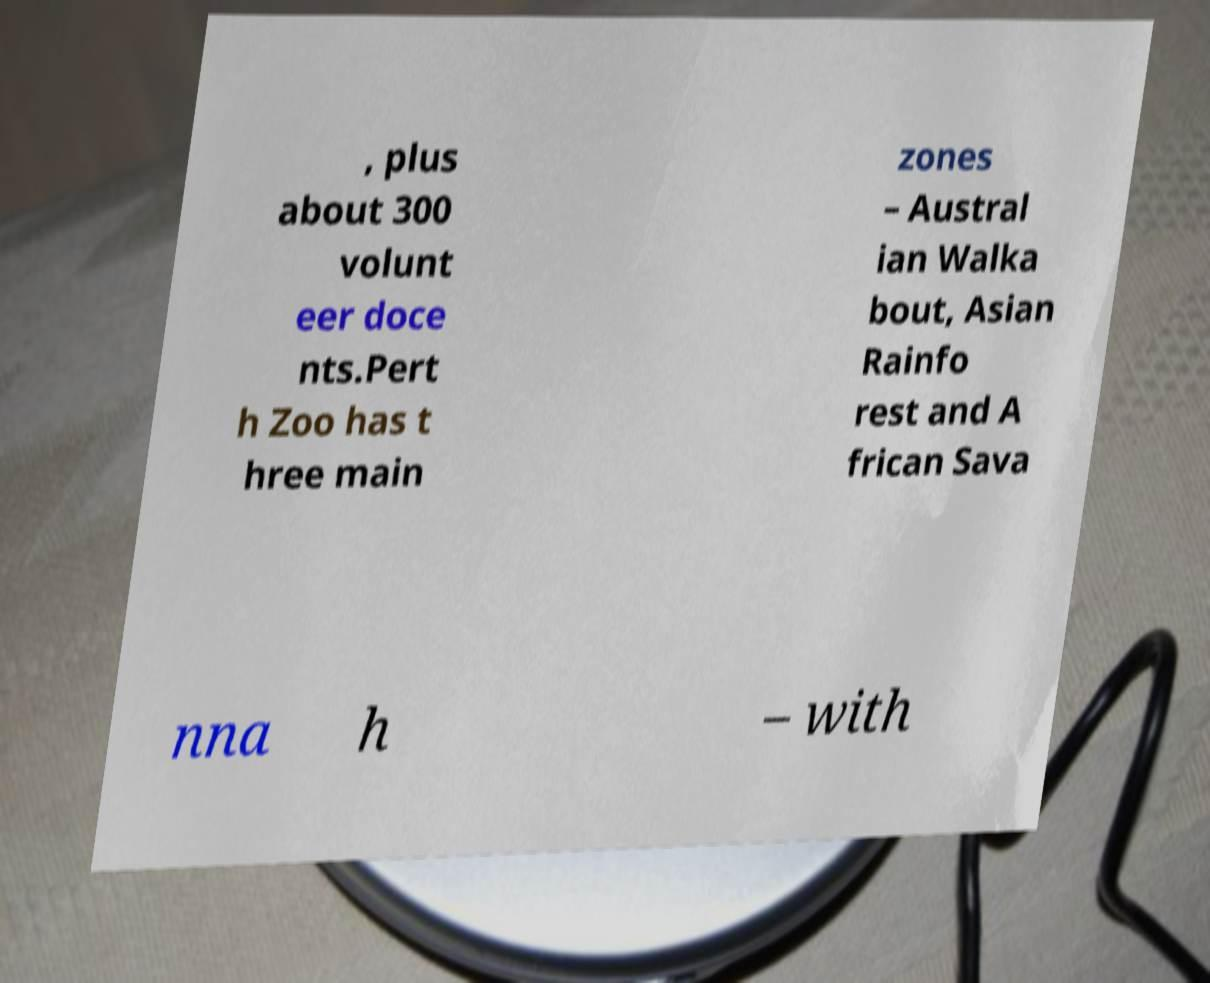Can you read and provide the text displayed in the image?This photo seems to have some interesting text. Can you extract and type it out for me? , plus about 300 volunt eer doce nts.Pert h Zoo has t hree main zones – Austral ian Walka bout, Asian Rainfo rest and A frican Sava nna h – with 